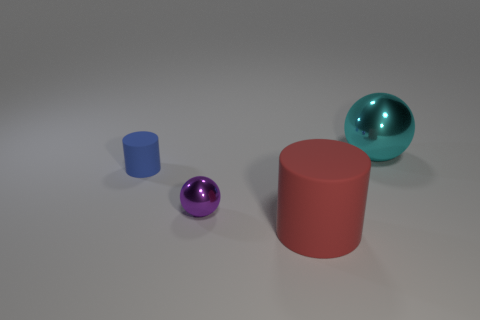What material do the objects seem to be made from? The objects in the image appear to be rendered with a solid, likely plastic or metal-like material. The red cylinder and the purple sphere have glossy surfaces, indicating a reflective coating, while the blue sphere and smaller cylinder exhibit a matte finish. 